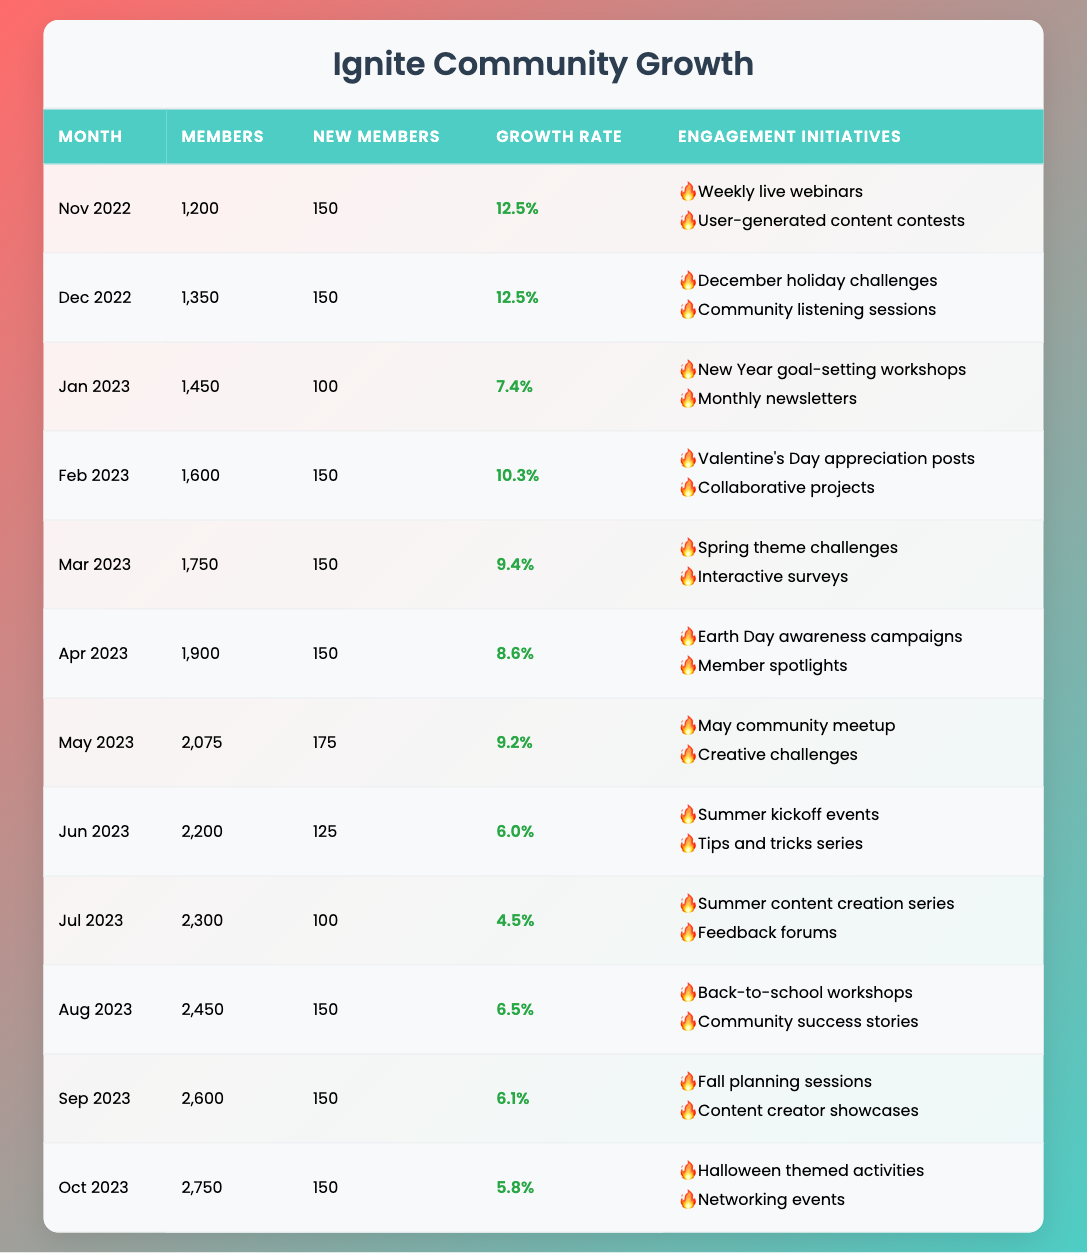What was the membership count in March 2023? The table shows that in March 2023, the membership count was listed as 1,750.
Answer: 1,750 What engagement initiative was highlighted in October 2023? According to the table, in October 2023, the engagement initiatives included "Halloween themed activities" and "Networking events."
Answer: Halloween themed activities, Networking events In which month did the Ignite community experience the highest growth rate? By examining the growth rate column, the highest rate of 12.5% occurred in both November and December 2022.
Answer: November and December 2022 What was the total number of new members from November 2022 to January 2023? Summing the new members from November (150), December (150), and January (100), we get 150 + 150 + 100 = 400.
Answer: 400 Did the membership count decrease at any point during the year? The membership count consistently increased month by month; thus, there was never a decrease.
Answer: No What was the average growth rate from January 2023 to October 2023? The growth rates for these months are 7.4, 10.3, 9.4, 8.6, 9.2, 6.0, 4.5, 6.5, 6.1, and 5.8, which sum to 8.71 and dividing by 10 gives an average of 8.71.
Answer: 8.71 Which month had the lowest number of new members and how many were there? Inspecting the new members column shows that July 2023 had the lowest at 100 new members.
Answer: July 2023, 100 What was the total membership count by the end of October 2023? The table indicates that the membership count in October 2023 was 2,750.
Answer: 2,750 What was the engagement initiative for May 2023? The table lists "May community meetup" and "Creative challenges" as the engagement initiatives for May 2023.
Answer: May community meetup, Creative challenges 